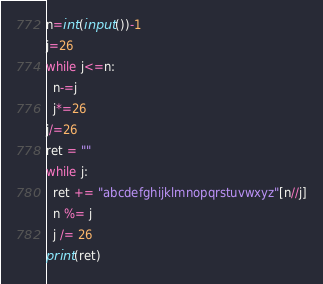<code> <loc_0><loc_0><loc_500><loc_500><_Python_>n=int(input())-1
j=26
while j<=n:
  n-=j
  j*=26
j/=26
ret = ""
while j:
  ret += "abcdefghijklmnopqrstuvwxyz"[n//j]
  n %= j
  j /= 26
print(ret)
</code> 